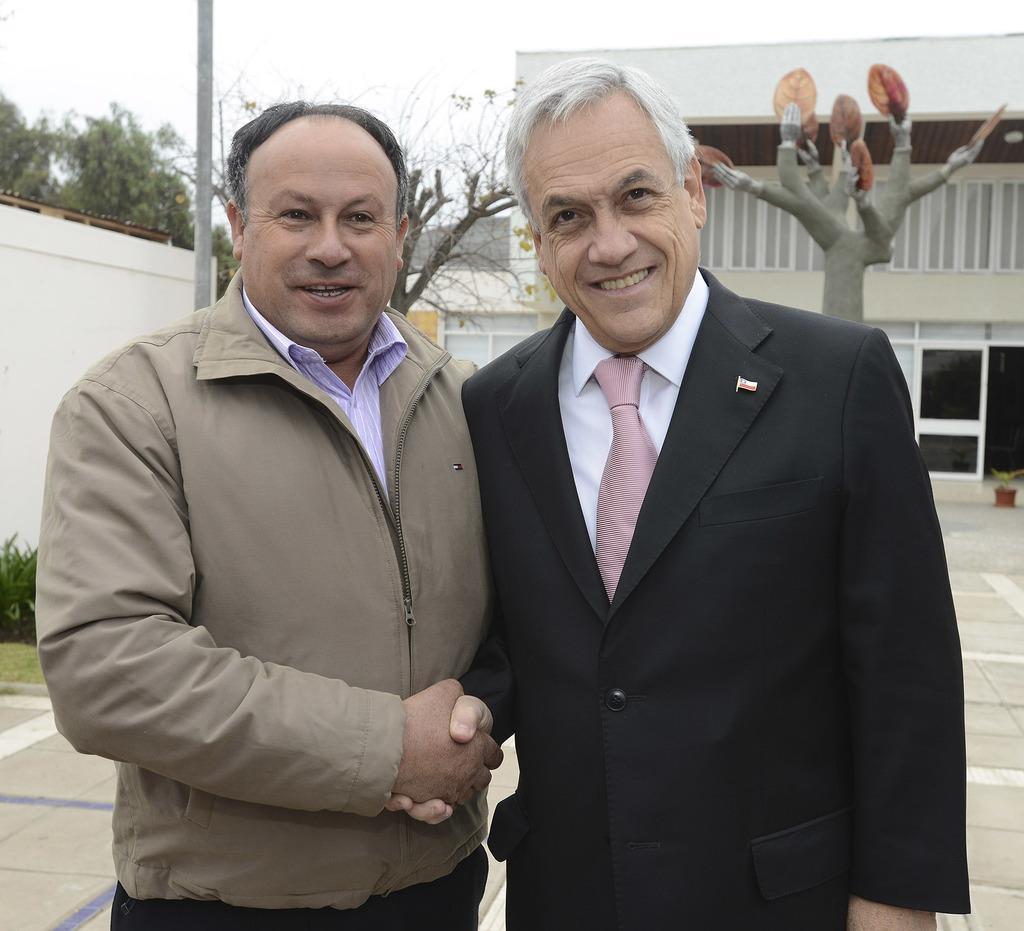Describe this image in one or two sentences. In the image we can see there are two men standing and behind them there are trees and there are buildings. 